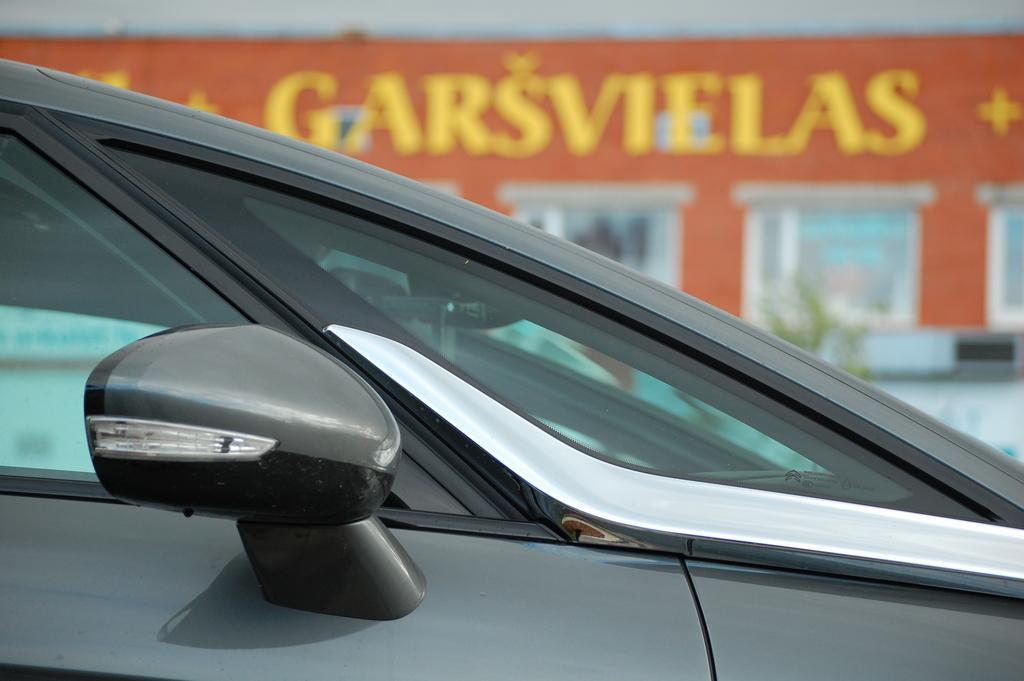Can you describe this image briefly? In this image we can see a vehicle which is truncated. There is a blur background and we can see a board, windows, and other objects. 